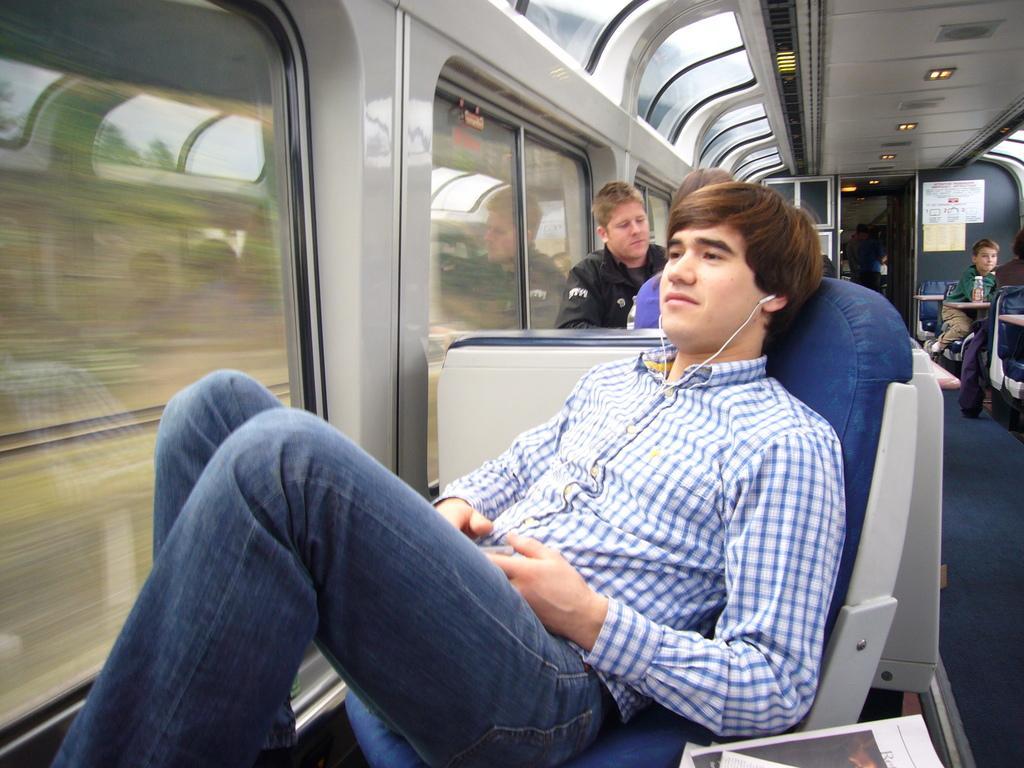In one or two sentences, can you explain what this image depicts? In this image I can see there were persons sitting on the chairs. And it looks like inside of the train. And the person holding an object. And there is a book, Board and a light. 